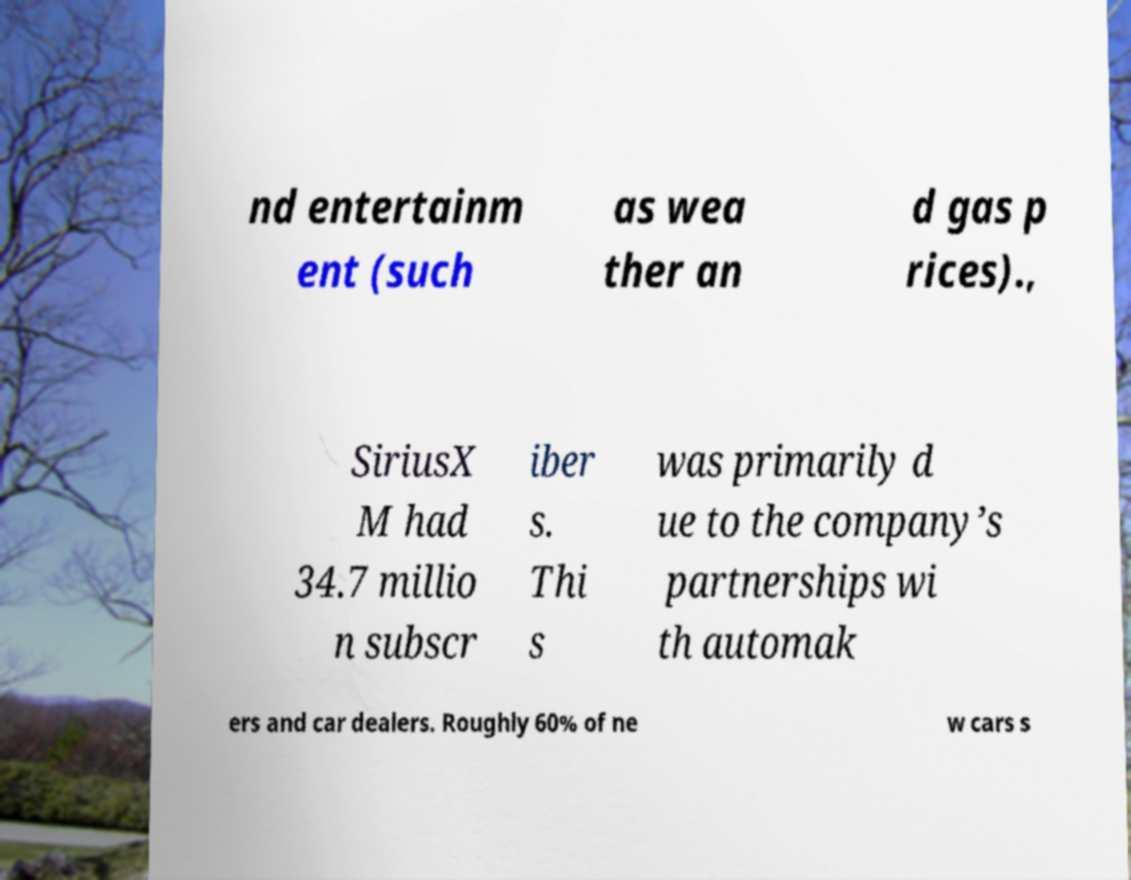Could you extract and type out the text from this image? nd entertainm ent (such as wea ther an d gas p rices)., SiriusX M had 34.7 millio n subscr iber s. Thi s was primarily d ue to the company’s partnerships wi th automak ers and car dealers. Roughly 60% of ne w cars s 